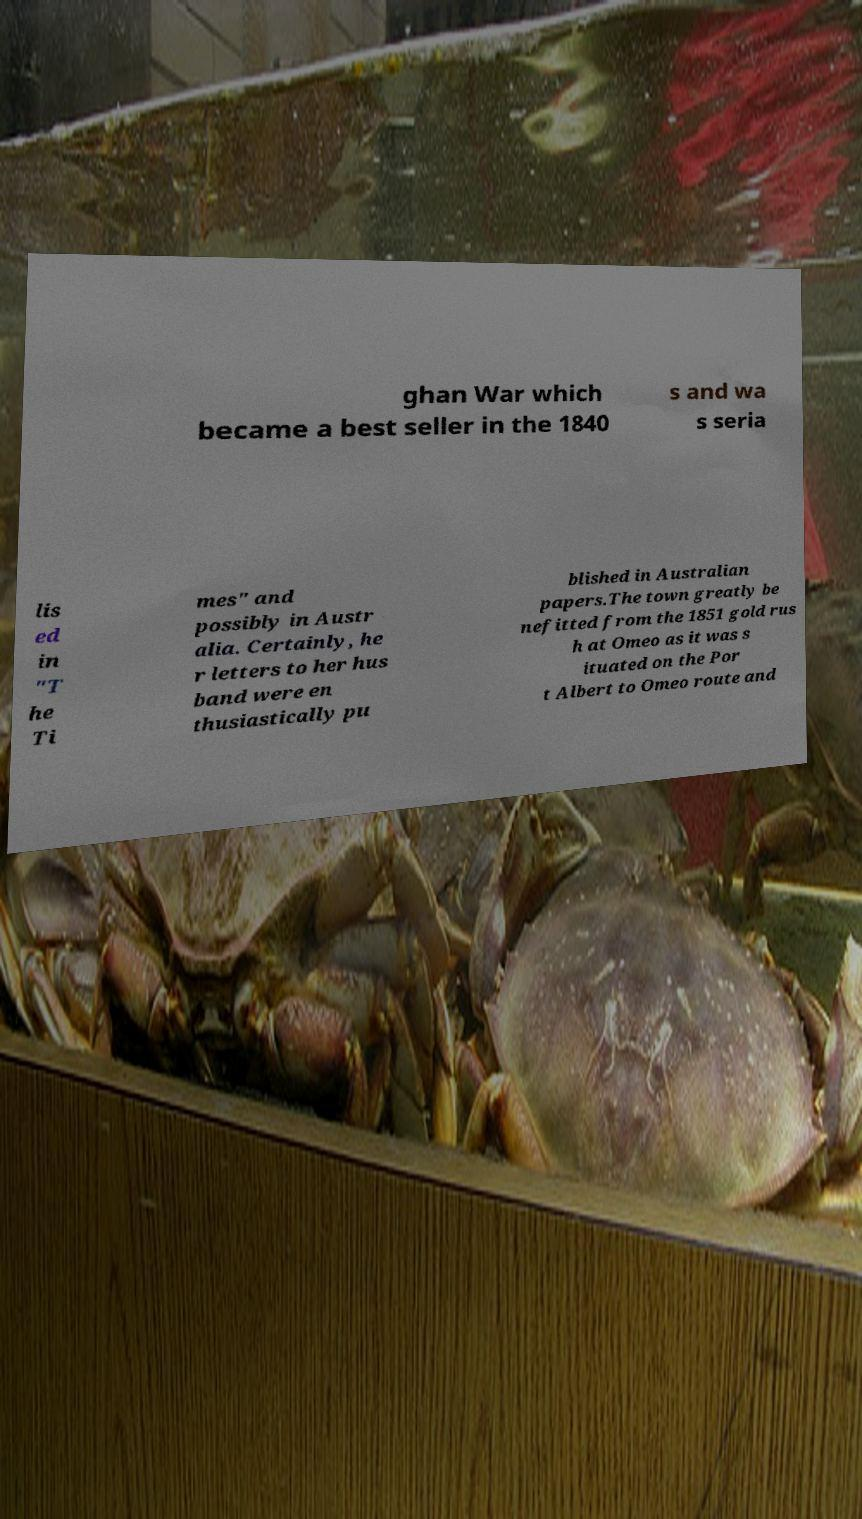Could you extract and type out the text from this image? ghan War which became a best seller in the 1840 s and wa s seria lis ed in "T he Ti mes" and possibly in Austr alia. Certainly, he r letters to her hus band were en thusiastically pu blished in Australian papers.The town greatly be nefitted from the 1851 gold rus h at Omeo as it was s ituated on the Por t Albert to Omeo route and 